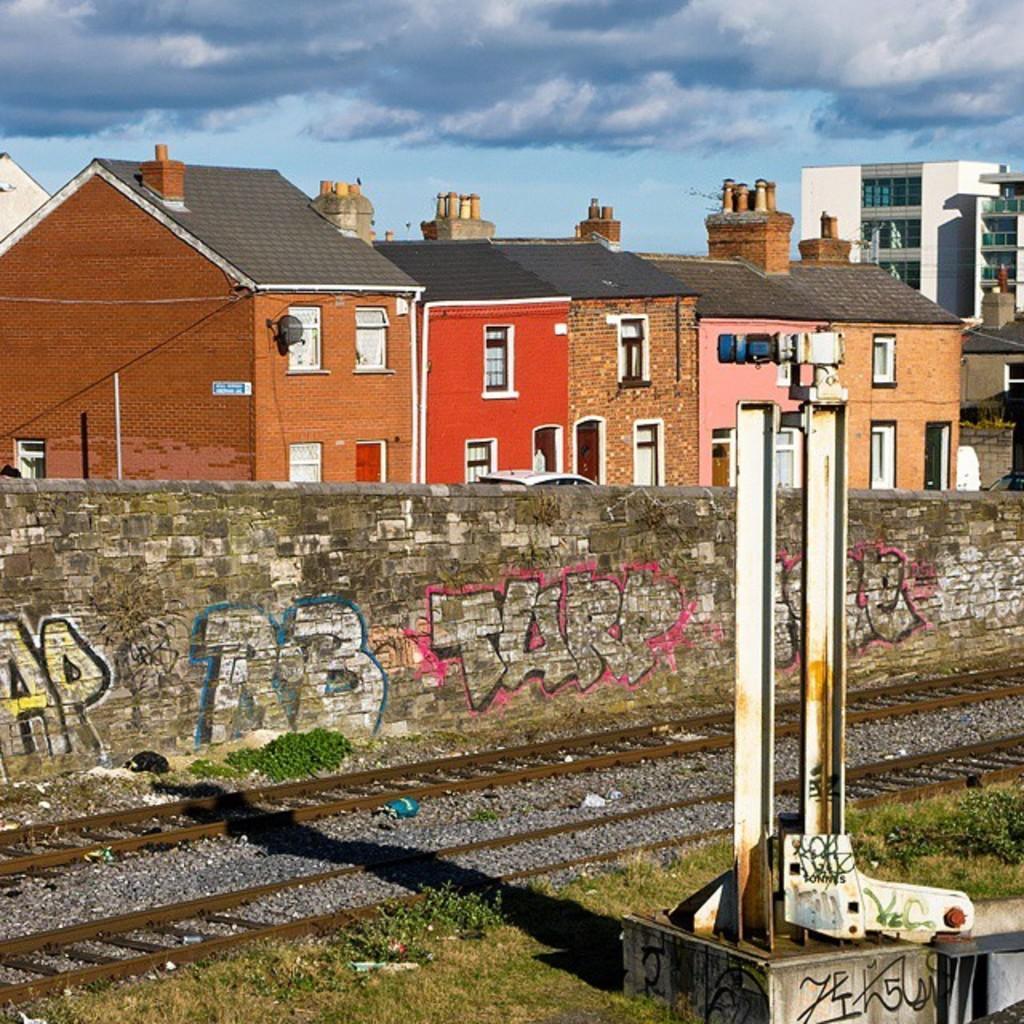Describe this image in one or two sentences. In the image I can see a place where we have some buildings, houses and also I can see a wall on which there is something written. 